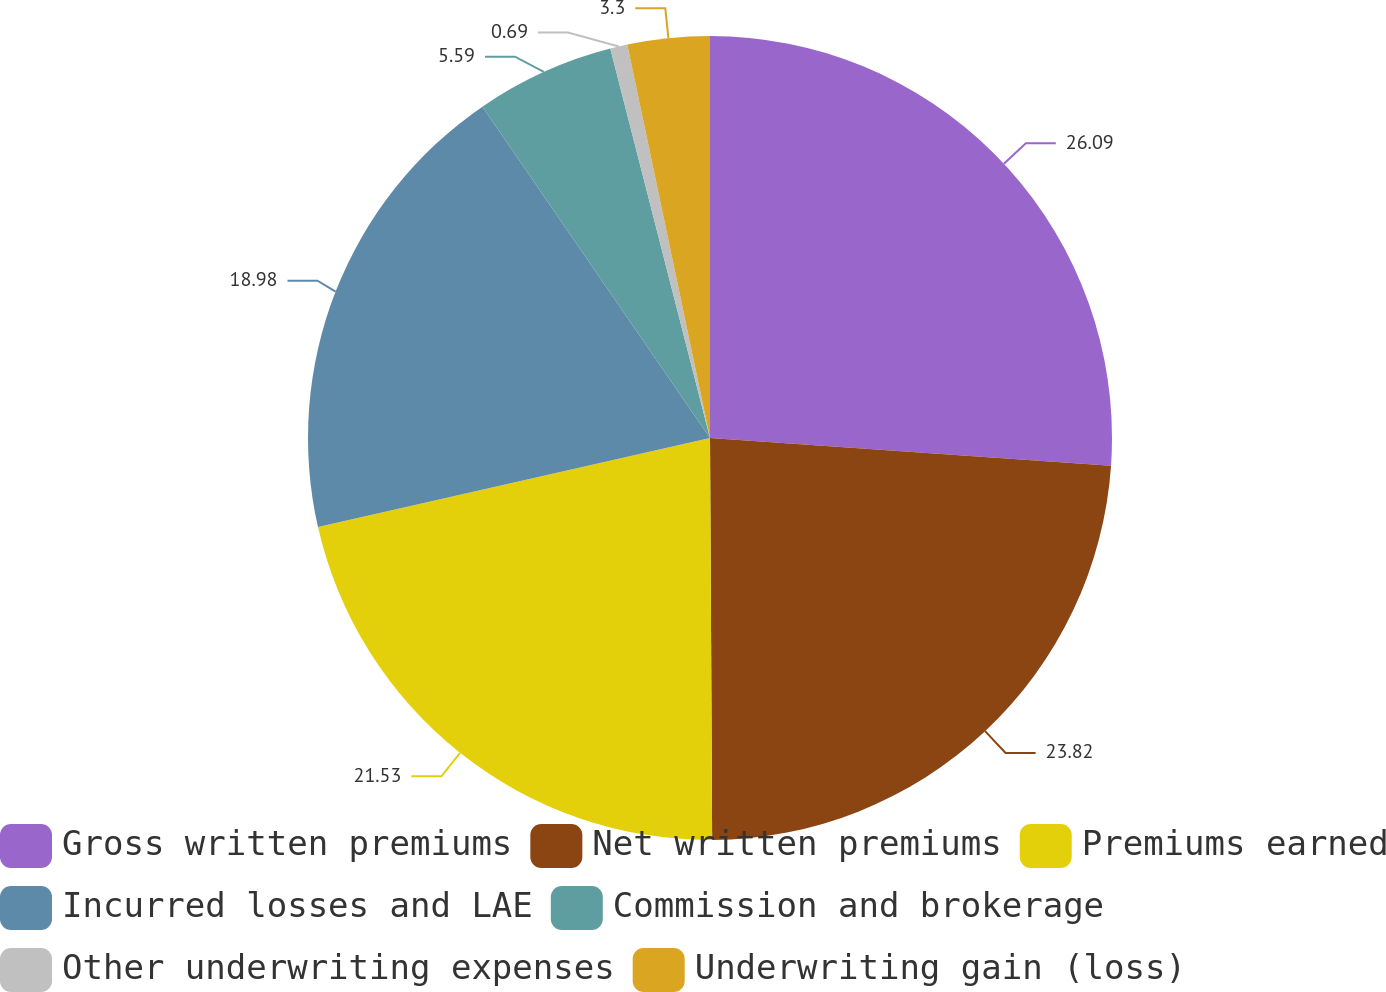<chart> <loc_0><loc_0><loc_500><loc_500><pie_chart><fcel>Gross written premiums<fcel>Net written premiums<fcel>Premiums earned<fcel>Incurred losses and LAE<fcel>Commission and brokerage<fcel>Other underwriting expenses<fcel>Underwriting gain (loss)<nl><fcel>26.1%<fcel>23.82%<fcel>21.53%<fcel>18.98%<fcel>5.59%<fcel>0.69%<fcel>3.3%<nl></chart> 